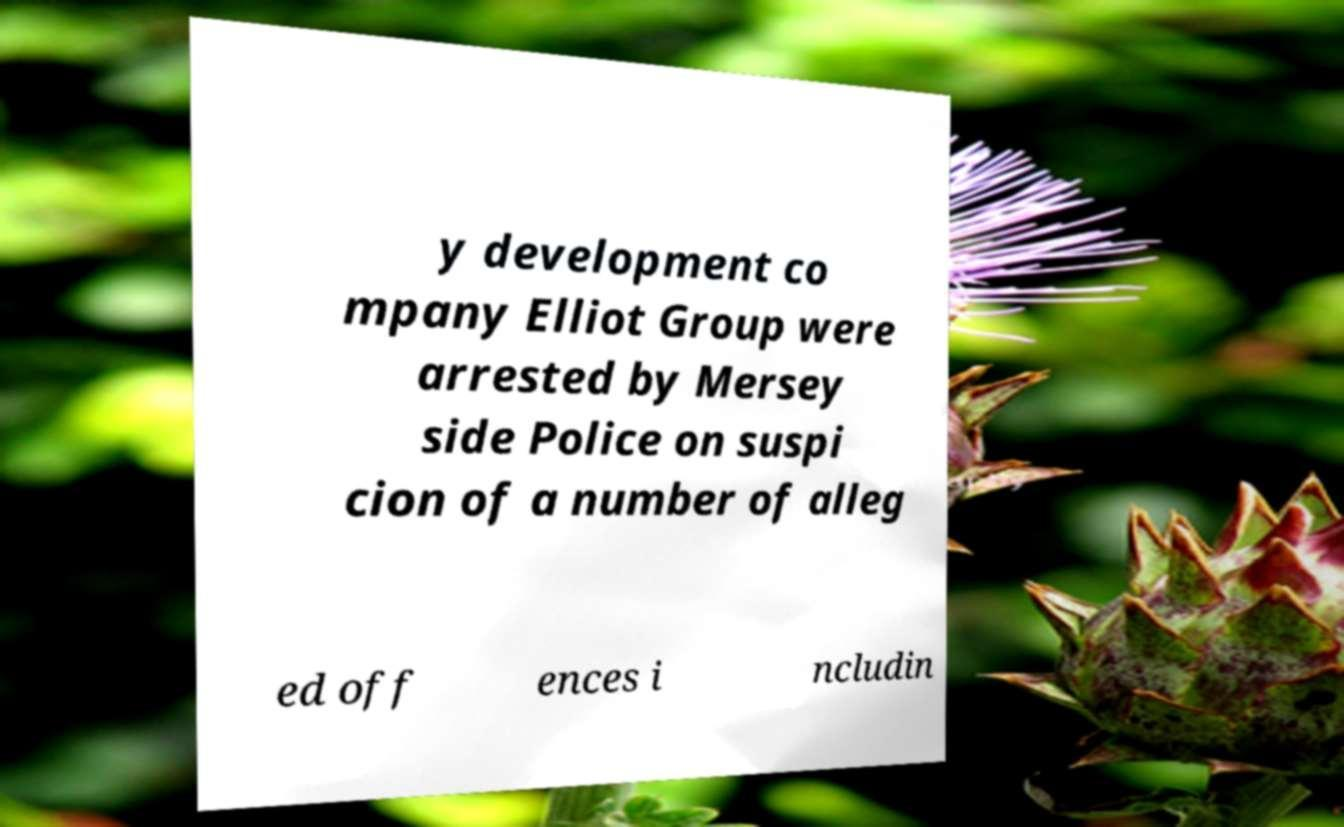Could you assist in decoding the text presented in this image and type it out clearly? y development co mpany Elliot Group were arrested by Mersey side Police on suspi cion of a number of alleg ed off ences i ncludin 